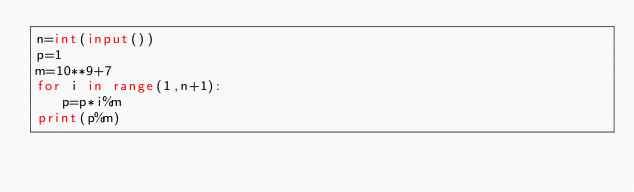<code> <loc_0><loc_0><loc_500><loc_500><_Python_>n=int(input())
p=1
m=10**9+7
for i in range(1,n+1):
   p=p*i%m
print(p%m)
</code> 